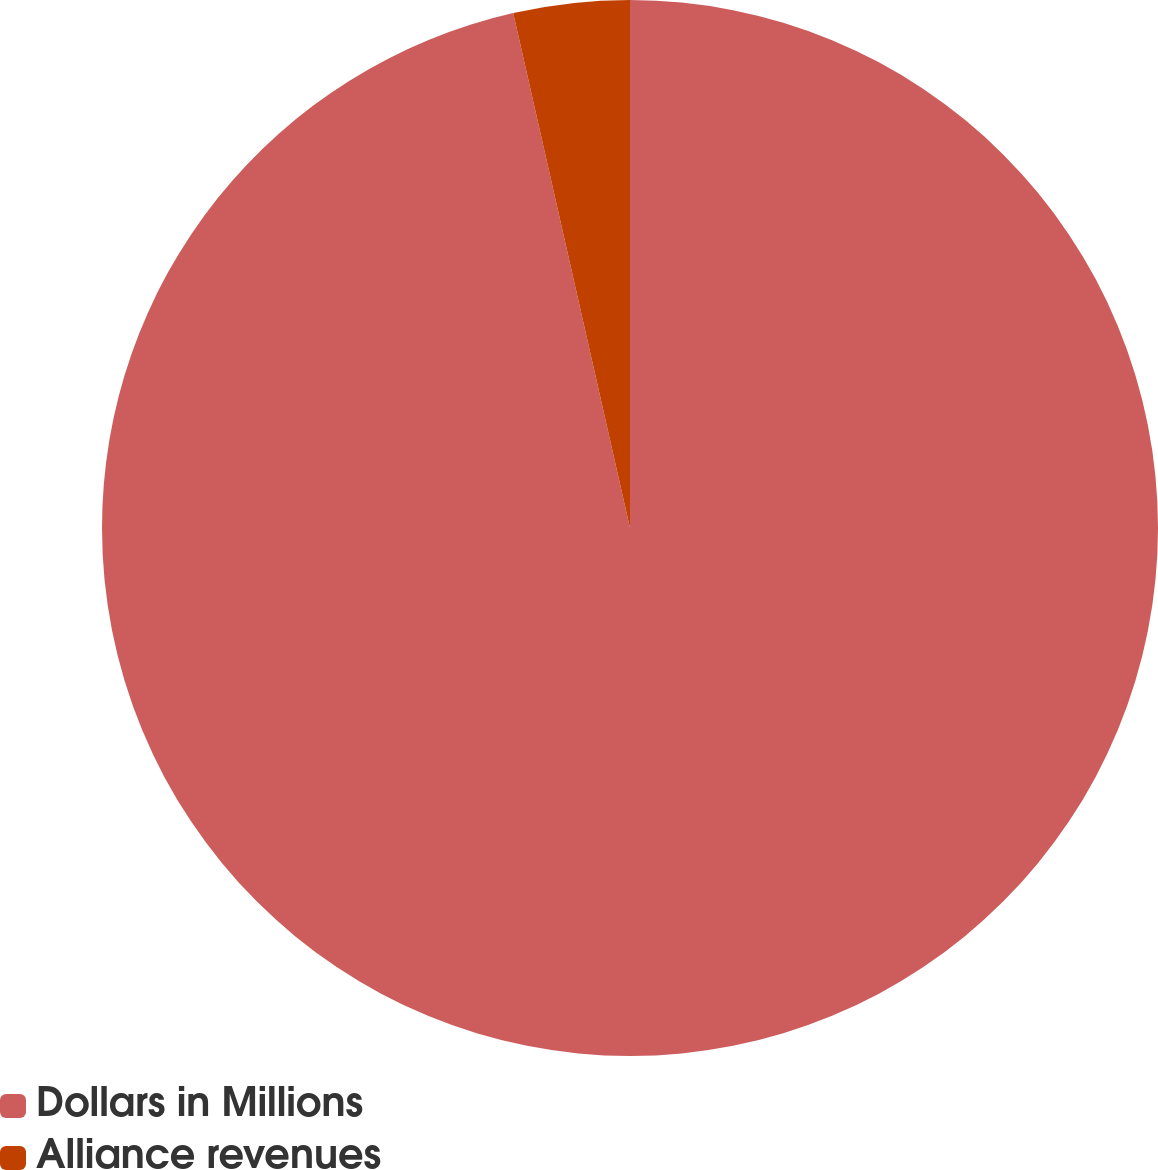Convert chart to OTSL. <chart><loc_0><loc_0><loc_500><loc_500><pie_chart><fcel>Dollars in Millions<fcel>Alliance revenues<nl><fcel>96.45%<fcel>3.55%<nl></chart> 